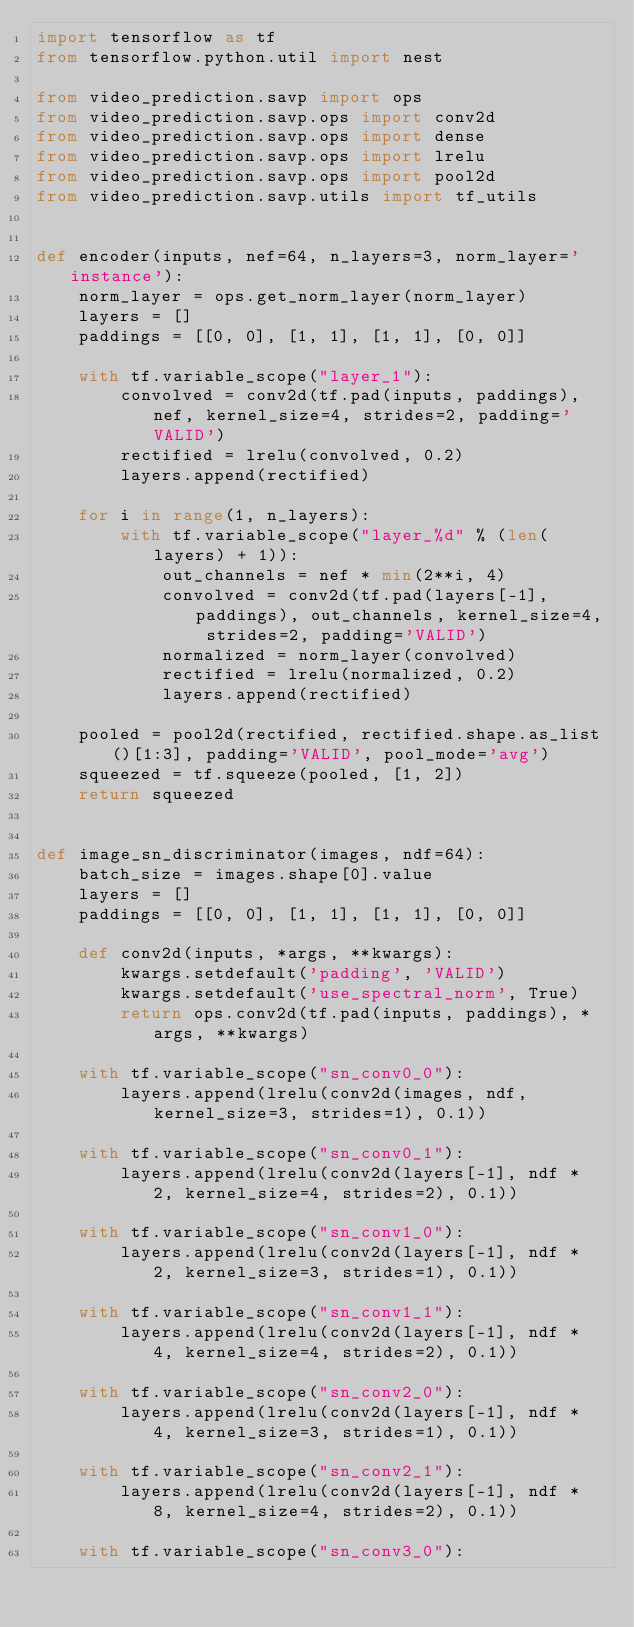<code> <loc_0><loc_0><loc_500><loc_500><_Python_>import tensorflow as tf
from tensorflow.python.util import nest

from video_prediction.savp import ops
from video_prediction.savp.ops import conv2d
from video_prediction.savp.ops import dense
from video_prediction.savp.ops import lrelu
from video_prediction.savp.ops import pool2d
from video_prediction.savp.utils import tf_utils


def encoder(inputs, nef=64, n_layers=3, norm_layer='instance'):
    norm_layer = ops.get_norm_layer(norm_layer)
    layers = []
    paddings = [[0, 0], [1, 1], [1, 1], [0, 0]]

    with tf.variable_scope("layer_1"):
        convolved = conv2d(tf.pad(inputs, paddings), nef, kernel_size=4, strides=2, padding='VALID')
        rectified = lrelu(convolved, 0.2)
        layers.append(rectified)

    for i in range(1, n_layers):
        with tf.variable_scope("layer_%d" % (len(layers) + 1)):
            out_channels = nef * min(2**i, 4)
            convolved = conv2d(tf.pad(layers[-1], paddings), out_channels, kernel_size=4, strides=2, padding='VALID')
            normalized = norm_layer(convolved)
            rectified = lrelu(normalized, 0.2)
            layers.append(rectified)

    pooled = pool2d(rectified, rectified.shape.as_list()[1:3], padding='VALID', pool_mode='avg')
    squeezed = tf.squeeze(pooled, [1, 2])
    return squeezed


def image_sn_discriminator(images, ndf=64):
    batch_size = images.shape[0].value
    layers = []
    paddings = [[0, 0], [1, 1], [1, 1], [0, 0]]

    def conv2d(inputs, *args, **kwargs):
        kwargs.setdefault('padding', 'VALID')
        kwargs.setdefault('use_spectral_norm', True)
        return ops.conv2d(tf.pad(inputs, paddings), *args, **kwargs)

    with tf.variable_scope("sn_conv0_0"):
        layers.append(lrelu(conv2d(images, ndf, kernel_size=3, strides=1), 0.1))

    with tf.variable_scope("sn_conv0_1"):
        layers.append(lrelu(conv2d(layers[-1], ndf * 2, kernel_size=4, strides=2), 0.1))

    with tf.variable_scope("sn_conv1_0"):
        layers.append(lrelu(conv2d(layers[-1], ndf * 2, kernel_size=3, strides=1), 0.1))

    with tf.variable_scope("sn_conv1_1"):
        layers.append(lrelu(conv2d(layers[-1], ndf * 4, kernel_size=4, strides=2), 0.1))

    with tf.variable_scope("sn_conv2_0"):
        layers.append(lrelu(conv2d(layers[-1], ndf * 4, kernel_size=3, strides=1), 0.1))

    with tf.variable_scope("sn_conv2_1"):
        layers.append(lrelu(conv2d(layers[-1], ndf * 8, kernel_size=4, strides=2), 0.1))

    with tf.variable_scope("sn_conv3_0"):</code> 